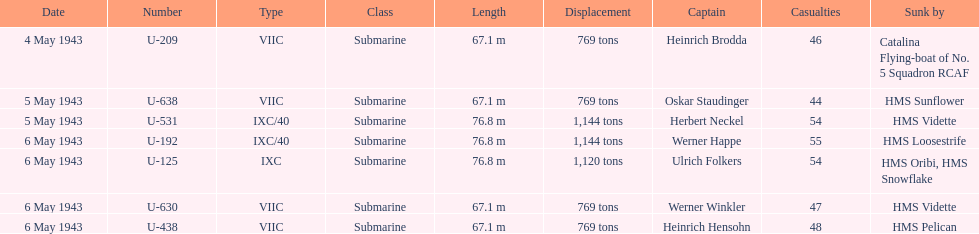Who were the captains in the ons 5 convoy? Heinrich Brodda, Oskar Staudinger, Herbert Neckel, Werner Happe, Ulrich Folkers, Werner Winkler, Heinrich Hensohn. Which ones lost their u-boat on may 5? Oskar Staudinger, Herbert Neckel. Of those, which one is not oskar staudinger? Herbert Neckel. 